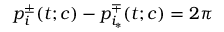<formula> <loc_0><loc_0><loc_500><loc_500>p _ { i } ^ { \pm } ( t ; c ) - p _ { i _ { * } } ^ { \mp } ( t ; c ) = 2 \pi</formula> 